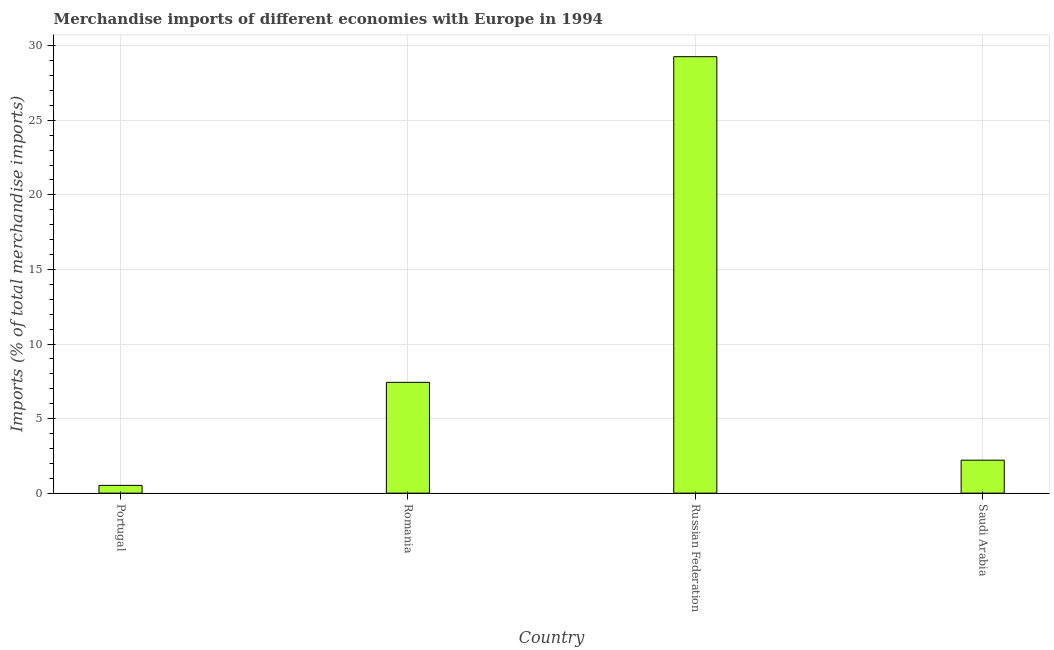Does the graph contain any zero values?
Keep it short and to the point. No. Does the graph contain grids?
Your answer should be compact. Yes. What is the title of the graph?
Provide a short and direct response. Merchandise imports of different economies with Europe in 1994. What is the label or title of the X-axis?
Give a very brief answer. Country. What is the label or title of the Y-axis?
Your response must be concise. Imports (% of total merchandise imports). What is the merchandise imports in Russian Federation?
Give a very brief answer. 29.26. Across all countries, what is the maximum merchandise imports?
Make the answer very short. 29.26. Across all countries, what is the minimum merchandise imports?
Offer a terse response. 0.52. In which country was the merchandise imports maximum?
Ensure brevity in your answer.  Russian Federation. What is the sum of the merchandise imports?
Provide a succinct answer. 39.42. What is the difference between the merchandise imports in Portugal and Russian Federation?
Provide a succinct answer. -28.74. What is the average merchandise imports per country?
Provide a short and direct response. 9.86. What is the median merchandise imports?
Your response must be concise. 4.82. In how many countries, is the merchandise imports greater than 20 %?
Your answer should be very brief. 1. What is the ratio of the merchandise imports in Romania to that in Saudi Arabia?
Ensure brevity in your answer.  3.36. What is the difference between the highest and the second highest merchandise imports?
Keep it short and to the point. 21.84. What is the difference between the highest and the lowest merchandise imports?
Provide a succinct answer. 28.74. In how many countries, is the merchandise imports greater than the average merchandise imports taken over all countries?
Ensure brevity in your answer.  1. Are all the bars in the graph horizontal?
Offer a very short reply. No. How many countries are there in the graph?
Provide a short and direct response. 4. What is the difference between two consecutive major ticks on the Y-axis?
Make the answer very short. 5. What is the Imports (% of total merchandise imports) of Portugal?
Provide a succinct answer. 0.52. What is the Imports (% of total merchandise imports) of Romania?
Provide a short and direct response. 7.43. What is the Imports (% of total merchandise imports) in Russian Federation?
Make the answer very short. 29.26. What is the Imports (% of total merchandise imports) of Saudi Arabia?
Your response must be concise. 2.21. What is the difference between the Imports (% of total merchandise imports) in Portugal and Romania?
Offer a terse response. -6.91. What is the difference between the Imports (% of total merchandise imports) in Portugal and Russian Federation?
Give a very brief answer. -28.74. What is the difference between the Imports (% of total merchandise imports) in Portugal and Saudi Arabia?
Your answer should be compact. -1.69. What is the difference between the Imports (% of total merchandise imports) in Romania and Russian Federation?
Offer a very short reply. -21.84. What is the difference between the Imports (% of total merchandise imports) in Romania and Saudi Arabia?
Keep it short and to the point. 5.22. What is the difference between the Imports (% of total merchandise imports) in Russian Federation and Saudi Arabia?
Offer a terse response. 27.05. What is the ratio of the Imports (% of total merchandise imports) in Portugal to that in Romania?
Make the answer very short. 0.07. What is the ratio of the Imports (% of total merchandise imports) in Portugal to that in Russian Federation?
Offer a terse response. 0.02. What is the ratio of the Imports (% of total merchandise imports) in Portugal to that in Saudi Arabia?
Offer a very short reply. 0.24. What is the ratio of the Imports (% of total merchandise imports) in Romania to that in Russian Federation?
Your response must be concise. 0.25. What is the ratio of the Imports (% of total merchandise imports) in Romania to that in Saudi Arabia?
Give a very brief answer. 3.36. What is the ratio of the Imports (% of total merchandise imports) in Russian Federation to that in Saudi Arabia?
Provide a short and direct response. 13.24. 